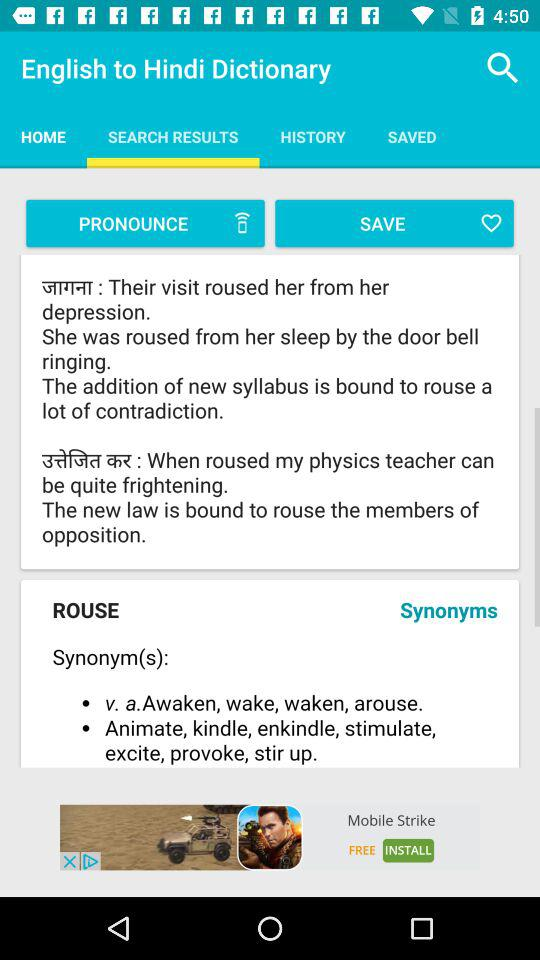What is the application name? The application name is "English to Hindi Dictionary". 